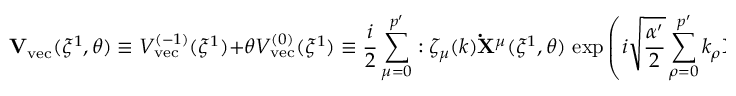Convert formula to latex. <formula><loc_0><loc_0><loc_500><loc_500>{ V } _ { v e c } ( \xi ^ { 1 } , \theta ) \equiv V _ { v e c } ^ { ( - 1 ) } ( \xi ^ { 1 } ) + \theta V _ { v e c } ^ { ( 0 ) } ( \xi ^ { 1 } ) \equiv \frac { i } { 2 } \sum _ { \mu = 0 } ^ { p ^ { \prime } } \colon \zeta _ { \mu } ( k ) { \dot { X } } ^ { \mu } ( \xi ^ { 1 } , \theta ) \, \exp \left ( i \sqrt { \frac { \alpha ^ { \prime } } { 2 } } \sum _ { \rho = 0 } ^ { p ^ { \prime } } k _ { \rho } { X } ^ { \rho } ( \xi ^ { 1 } , \theta ) \right ) \colon ,</formula> 